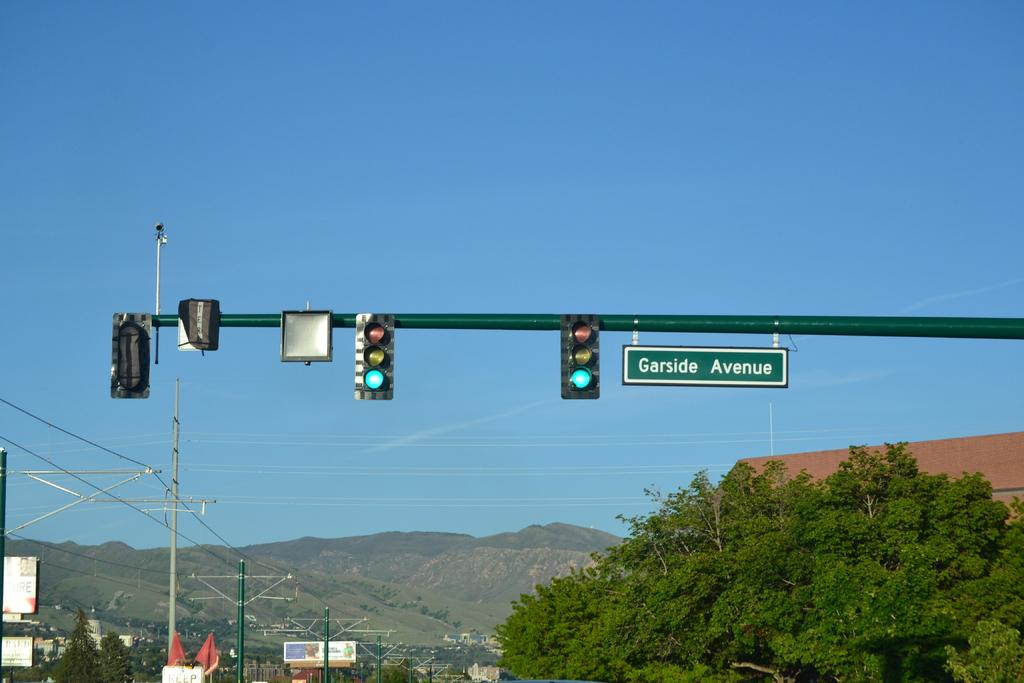<image>
Describe the image concisely. A shot of traffic lights turned green at Garside Avenue. 